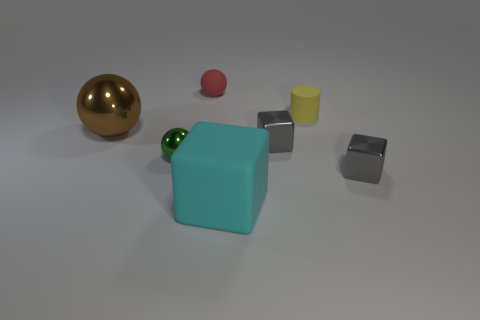Subtract all purple spheres. Subtract all blue cylinders. How many spheres are left? 3 Add 3 small cyan metal blocks. How many objects exist? 10 Subtract all blocks. How many objects are left? 4 Add 3 matte spheres. How many matte spheres are left? 4 Add 3 red metal blocks. How many red metal blocks exist? 3 Subtract 0 blue cylinders. How many objects are left? 7 Subtract all tiny green metal spheres. Subtract all small spheres. How many objects are left? 4 